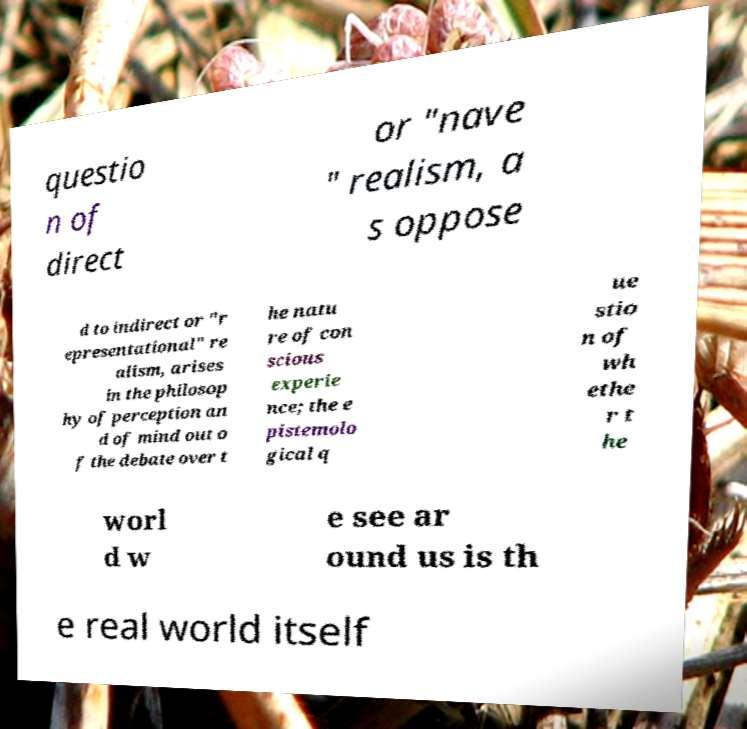I need the written content from this picture converted into text. Can you do that? questio n of direct or "nave " realism, a s oppose d to indirect or "r epresentational" re alism, arises in the philosop hy of perception an d of mind out o f the debate over t he natu re of con scious experie nce; the e pistemolo gical q ue stio n of wh ethe r t he worl d w e see ar ound us is th e real world itself 